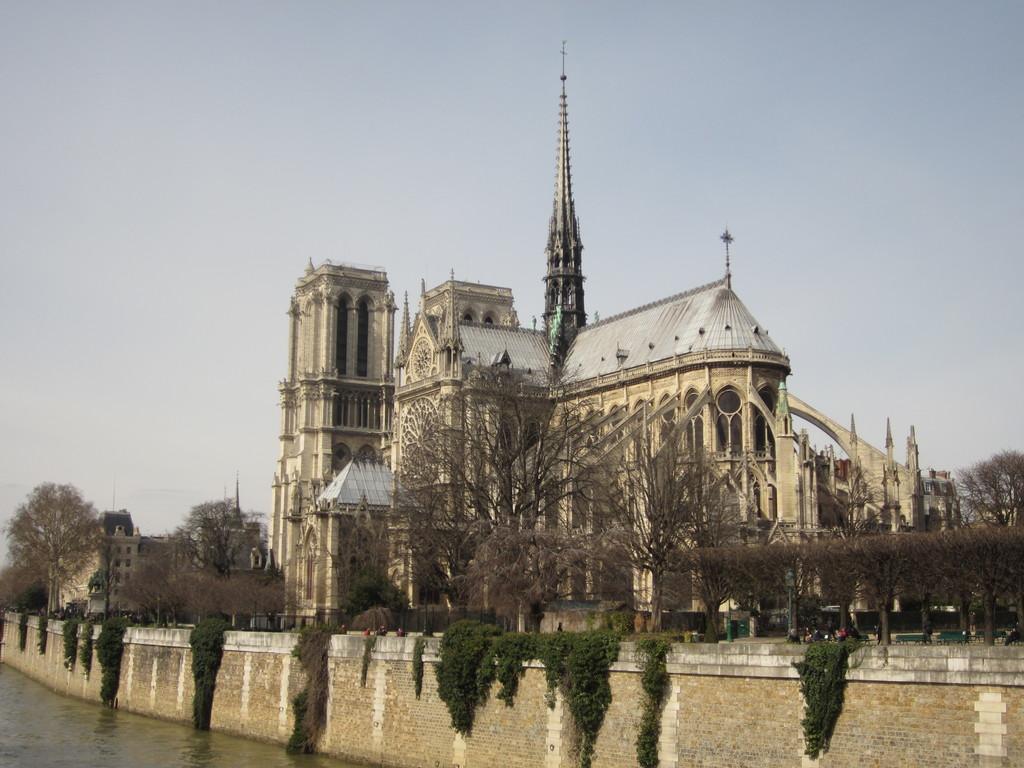Could you give a brief overview of what you see in this image? In this picture we can see a wall an behind the wall there are trees, buildings and a sky. On the left side of the wall there is water. 